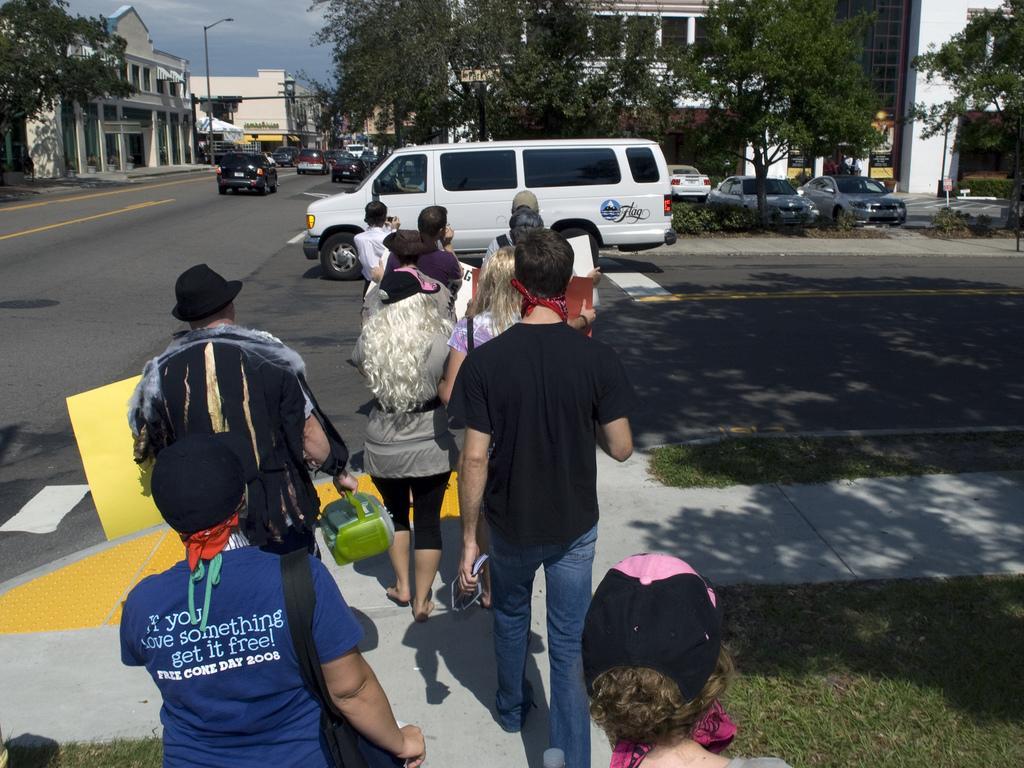Describe this image in one or two sentences. In this image there are some persons are crossing the road as we can see on the bottom of this image. There is a road in middle of this image. There are some trees on the top of this image and there are some buildings in the background. There is a sky on the top of this image. 